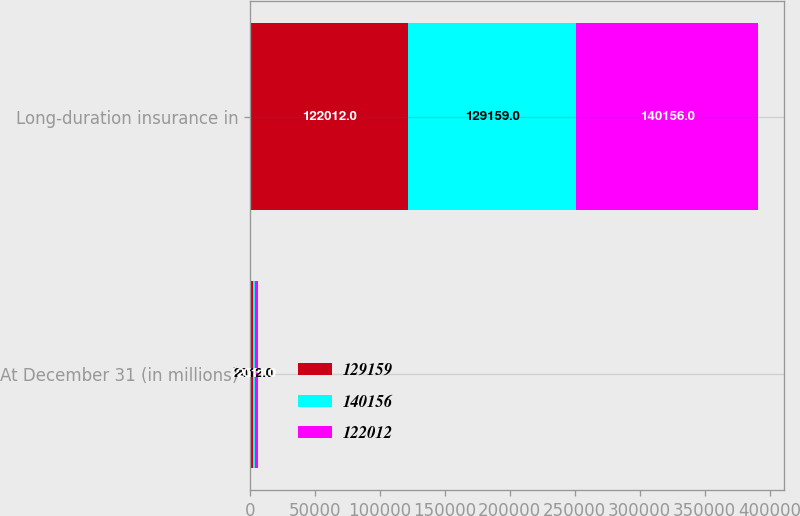Convert chart to OTSL. <chart><loc_0><loc_0><loc_500><loc_500><stacked_bar_chart><ecel><fcel>At December 31 (in millions)<fcel>Long-duration insurance in<nl><fcel>129159<fcel>2013<fcel>122012<nl><fcel>140156<fcel>2012<fcel>129159<nl><fcel>122012<fcel>2011<fcel>140156<nl></chart> 